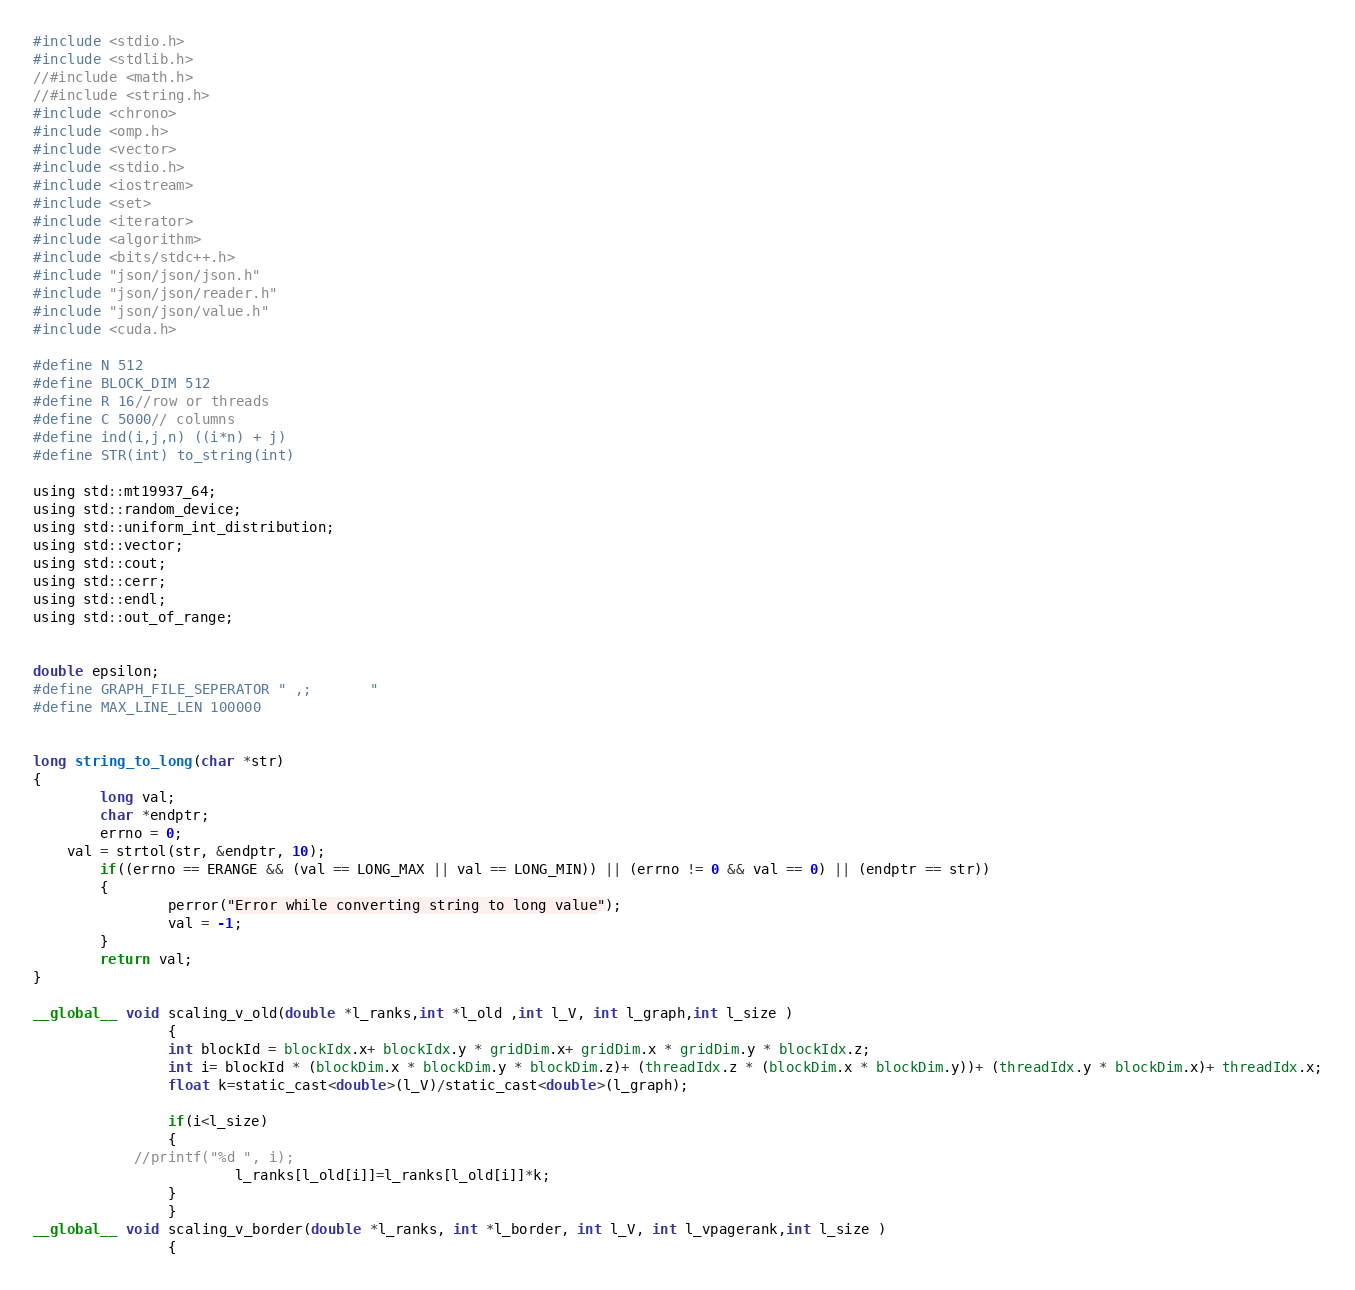<code> <loc_0><loc_0><loc_500><loc_500><_Cuda_>#include <stdio.h>
#include <stdlib.h>
//#include <math.h>
//#include <string.h>
#include <chrono>
#include <omp.h>
#include <vector>
#include <stdio.h>
#include <iostream>
#include <set>
#include <iterator>
#include <algorithm>
#include <bits/stdc++.h>
#include "json/json/json.h"
#include "json/json/reader.h"
#include "json/json/value.h"
#include <cuda.h>

#define N 512
#define BLOCK_DIM 512
#define R 16//row or threads
#define C 5000// columns
#define ind(i,j,n) ((i*n) + j)
#define STR(int) to_string(int)

using std::mt19937_64;
using std::random_device;
using std::uniform_int_distribution;
using std::vector;
using std::cout;
using std::cerr;
using std::endl;
using std::out_of_range;


double epsilon;
#define GRAPH_FILE_SEPERATOR " ,;       "
#define MAX_LINE_LEN 100000


long string_to_long(char *str)
{
        long val;
        char *endptr;
        errno = 0;
    val = strtol(str, &endptr, 10);
        if((errno == ERANGE && (val == LONG_MAX || val == LONG_MIN)) || (errno != 0 && val == 0) || (endptr == str))
        {
                perror("Error while converting string to long value");
                val = -1;
        }
        return val;
}

__global__ void scaling_v_old(double *l_ranks,int *l_old ,int l_V, int l_graph,int l_size )
                {
                int blockId = blockIdx.x+ blockIdx.y * gridDim.x+ gridDim.x * gridDim.y * blockIdx.z;
                int i= blockId * (blockDim.x * blockDim.y * blockDim.z)+ (threadIdx.z * (blockDim.x * blockDim.y))+ (threadIdx.y * blockDim.x)+ threadIdx.x;
                float k=static_cast<double>(l_V)/static_cast<double>(l_graph);
                
                if(i<l_size)
                {
			//printf("%d ", i);
                        l_ranks[l_old[i]]=l_ranks[l_old[i]]*k;
                }      
                }
__global__ void scaling_v_border(double *l_ranks, int *l_border, int l_V, int l_vpagerank,int l_size )
                {</code> 